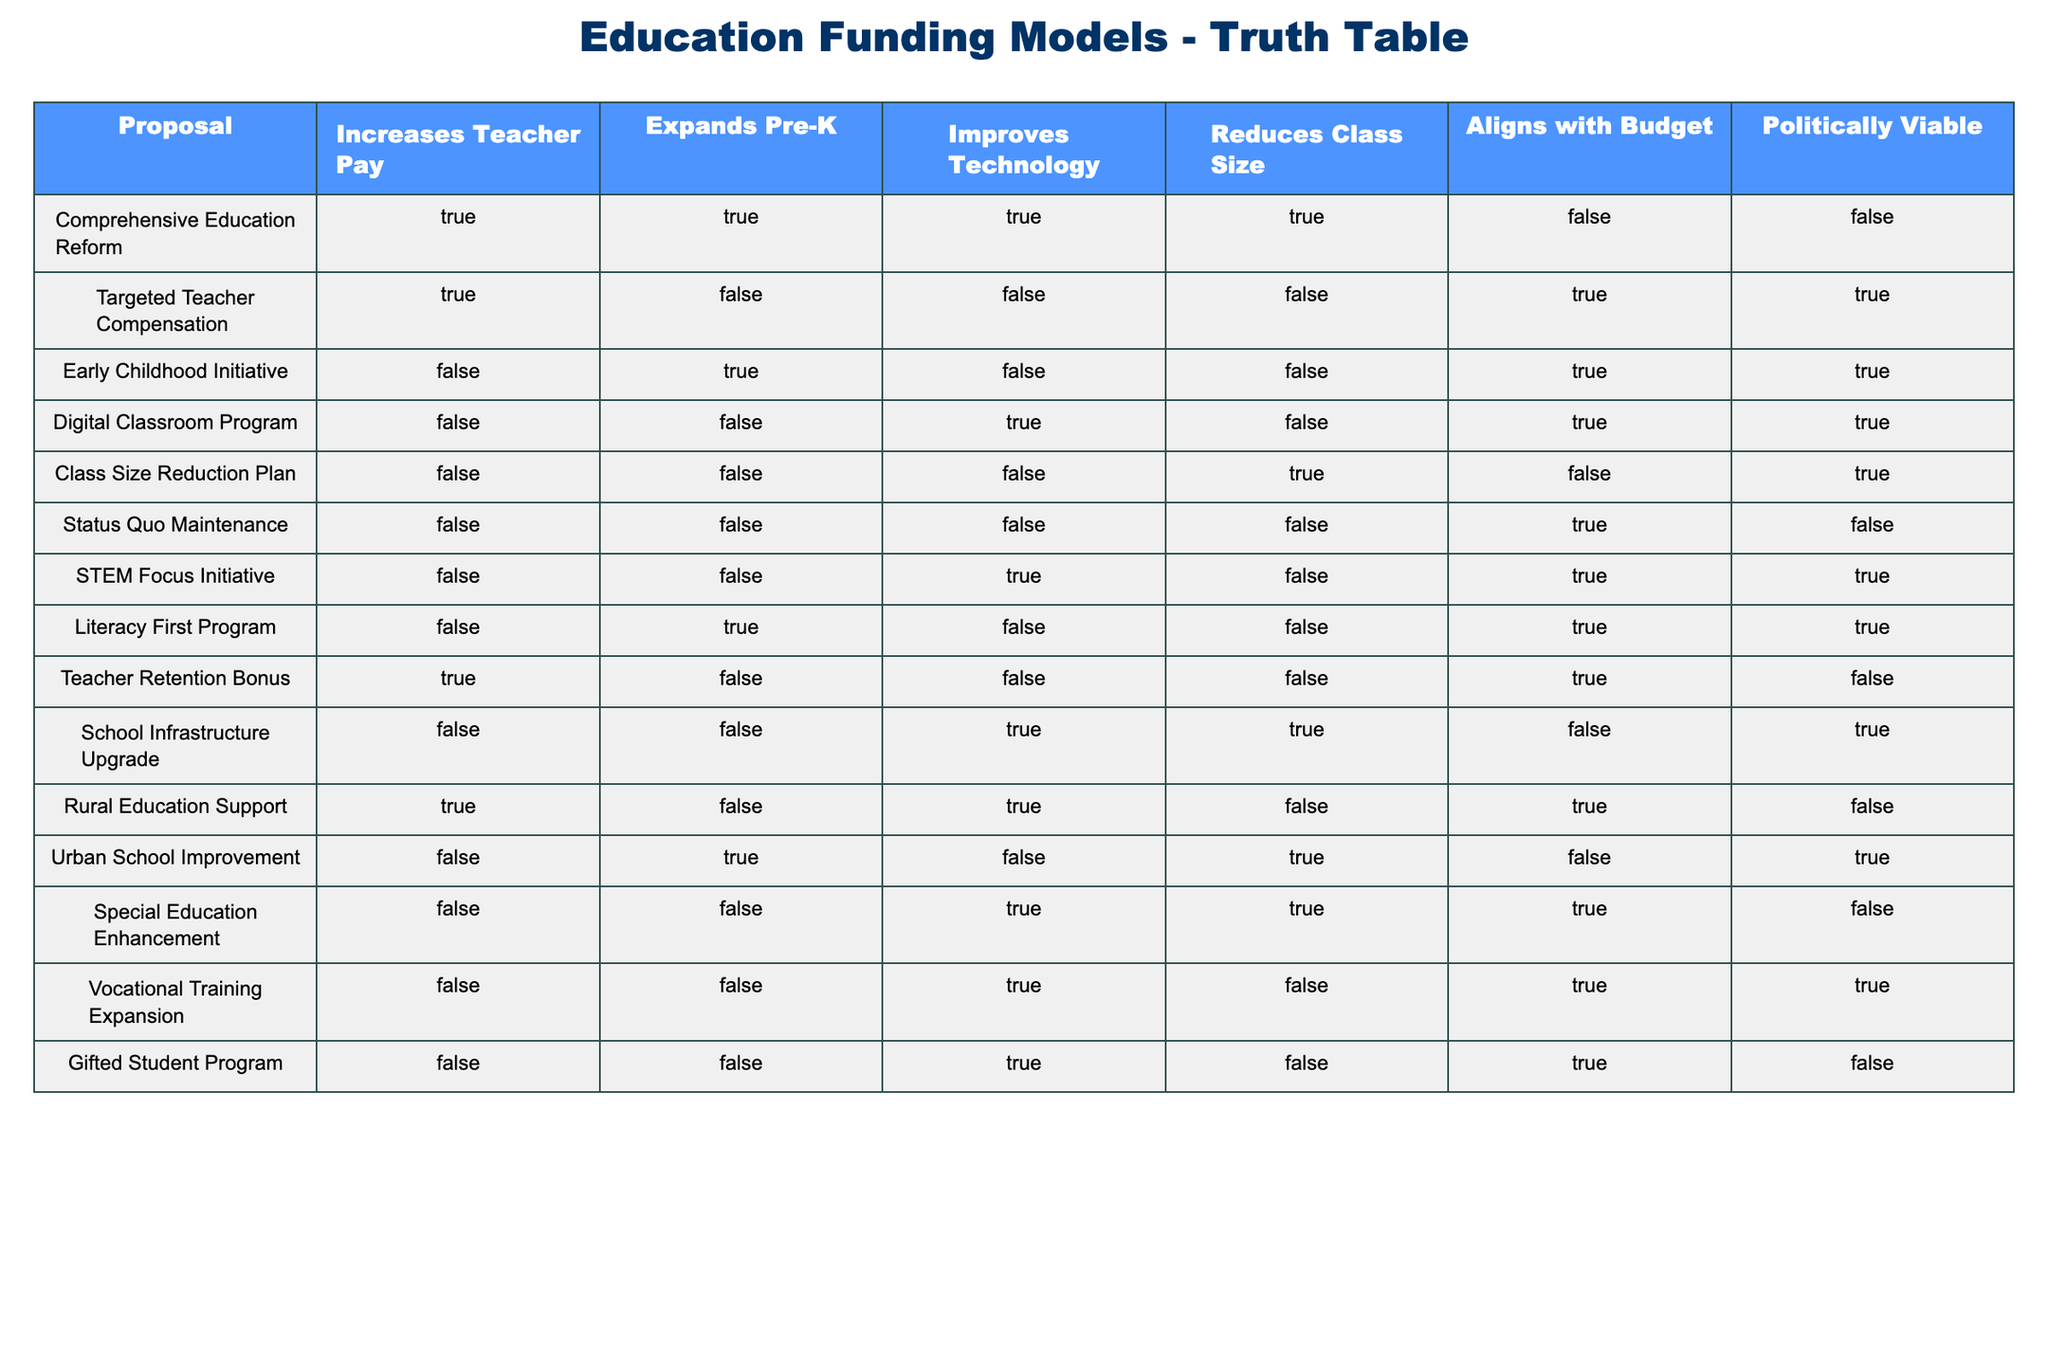What proposals increase teacher pay? Looking at the "Increases Teacher Pay" column, we can identify the proposals marked as TRUE: Comprehensive Education Reform, Targeted Teacher Compensation, Teacher Retention Bonus, and Rural Education Support.
Answer: Comprehensive Education Reform, Targeted Teacher Compensation, Teacher Retention Bonus, Rural Education Support Which proposals reduce class size? In the "Reduces Class Size" column, we check for TRUE values. The proposals that qualify are the Class Size Reduction Plan, School Infrastructure Upgrade, and Urban School Improvement.
Answer: Class Size Reduction Plan, School Infrastructure Upgrade, Urban School Improvement How many proposals align with the budget? By counting the number of TRUE entries in the "Aligns with Budget" column, we find that there are 5 proposals that meet this criterion: Targeted Teacher Compensation, Early Childhood Initiative, Digital Classroom Program, Vocational Training Expansion, Special Education Enhancement.
Answer: 5 Is the "Comprehensive Education Reform" proposal politically viable? Referring to the "Politically Viable" column, Comprehensive Education Reform is marked as FALSE.
Answer: No Which proposals focus on technology advancement? In the "Improves Technology" column, the proposals that are TRUE include the Digital Classroom Program, STEM Focus Initiative, School Infrastructure Upgrade, Vocational Training Expansion, and Gifted Student Program.
Answer: Digital Classroom Program, STEM Focus Initiative, School Infrastructure Upgrade, Vocational Training Expansion, Gifted Student Program How many proposals both increase teacher pay and expand Pre-K? We look for proposals that are TRUE in both the "Increases Teacher Pay" and "Expands Pre-K" columns. Upon inspection, only the Comprehensive Education Reform proposal meets both criteria, so the count is 1.
Answer: 1 Is there a proposal that improves technology but does not align with the budget? Analyzing the table, we find several proposals improving technology: Digital Classroom Program (TRUE), STEM Focus Initiative (TRUE), School Infrastructure Upgrade (TRUE), and Vocational Training Expansion (TRUE). Of these, the School Infrastructure Upgrade is the only one that does not align with the budget (FALSE). This checks out confirming the existence of such a proposal.
Answer: Yes What percentage of proposals expands Pre-K and reduces class size? We first find the proposals that are TRUE for both "Expands Pre-K" and "Reduces Class Size". The only qualifying proposal is the Urban School Improvement. Since there are a total of 12 proposals, the percentage is (1/12) * 100 = 8.33%.
Answer: 8.33% Which proposals do not expand Pre-K and are also politically viable? In the "Expands Pre-K" column, we filter the proposals marked FALSE and then check the "Politically Viable" column for TRUE. The proposals that meet these criteria are the Digital Classroom Program, Class Size Reduction Plan, Teacher Retention Bonus, and Gifted Student Program.
Answer: Digital Classroom Program, Class Size Reduction Plan, Teacher Retention Bonus, Gifted Student Program 